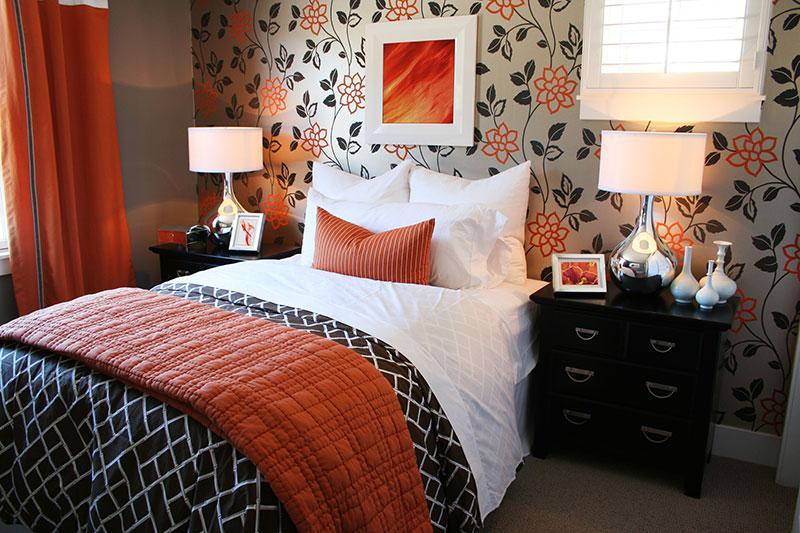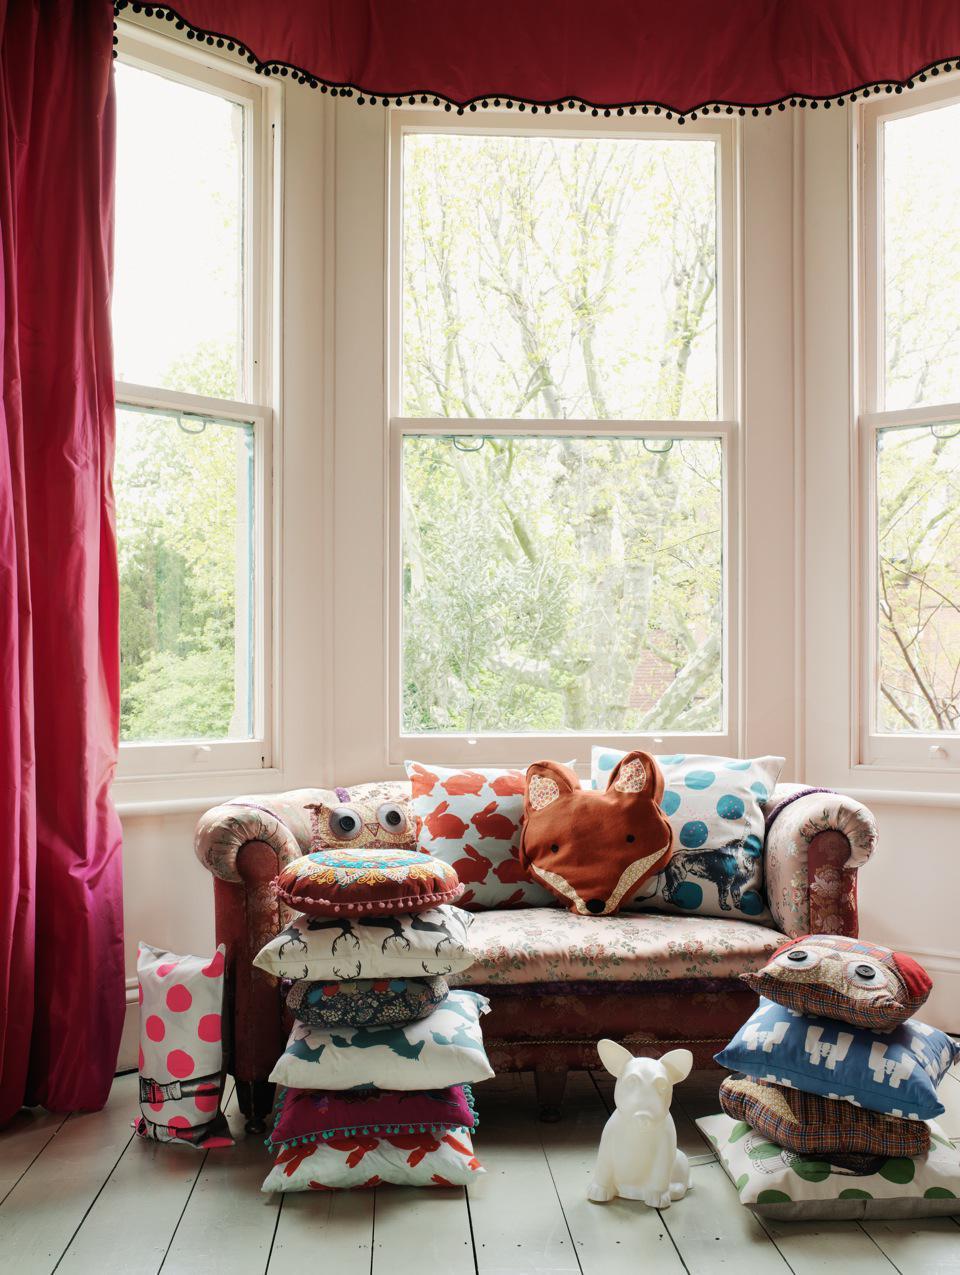The first image is the image on the left, the second image is the image on the right. For the images shown, is this caption "All images appear to be couches." true? Answer yes or no. No. 